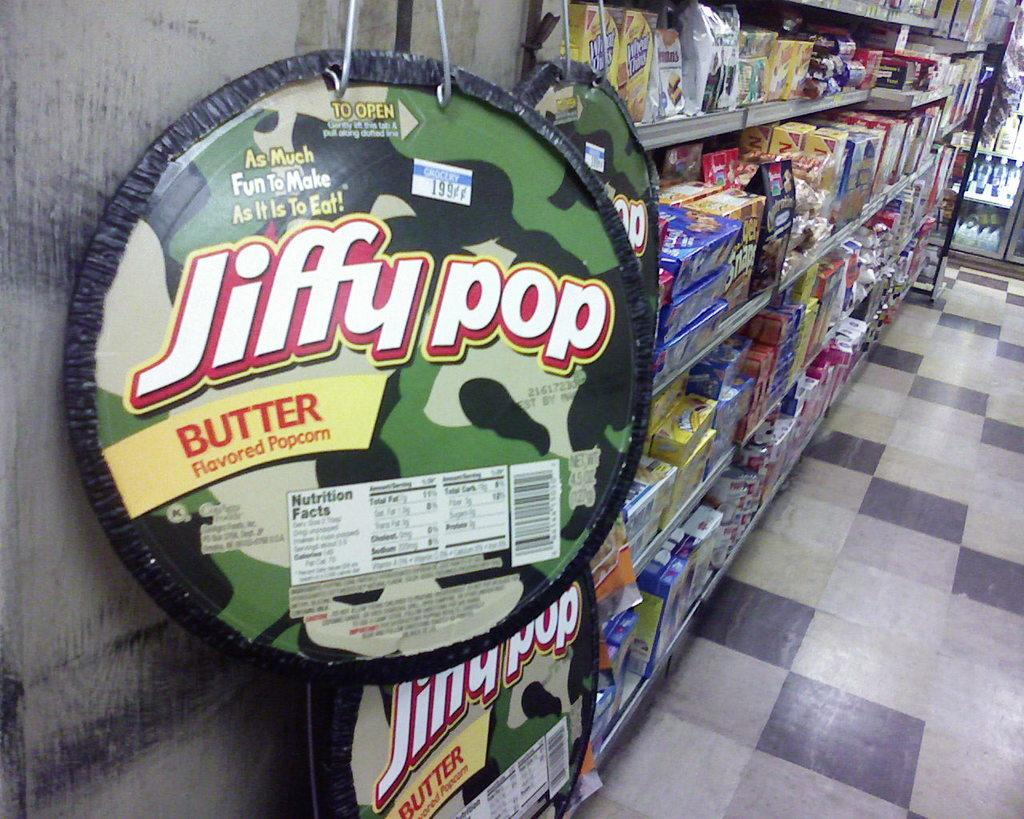<image>
Offer a succinct explanation of the picture presented. jiffy pop popcorn on display at the grocery store 